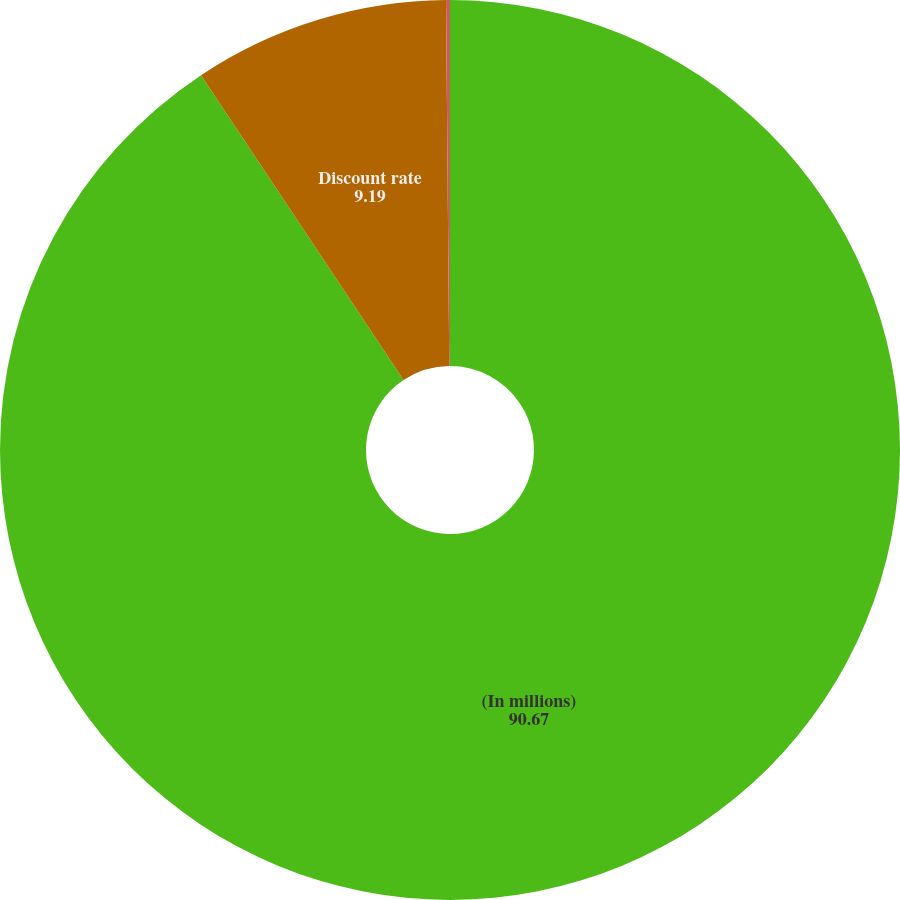<chart> <loc_0><loc_0><loc_500><loc_500><pie_chart><fcel>(In millions)<fcel>Discount rate<fcel>Average rate of increase in<nl><fcel>90.67%<fcel>9.19%<fcel>0.14%<nl></chart> 